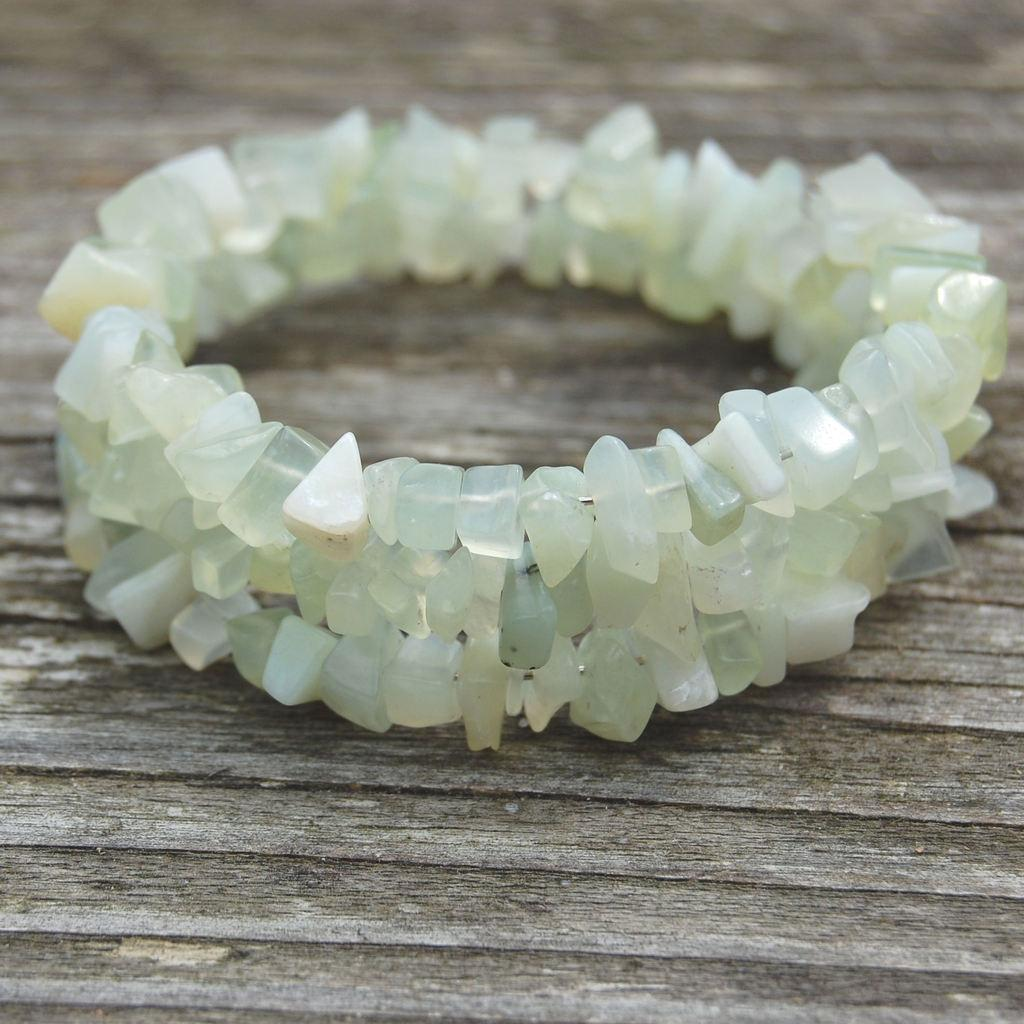What type of jewelry is present in the image? There is a crystal bracelet in the image. Where is the crystal bracelet placed in the image? The crystal bracelet is kept on a wooden surface. What type of soup is being served in the bedroom at night in the image? There is no soup or bedroom present in the image; it only features a crystal bracelet on a wooden surface. 